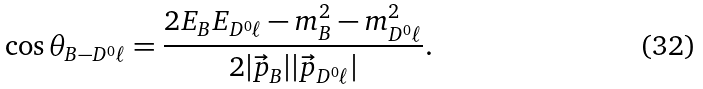<formula> <loc_0><loc_0><loc_500><loc_500>\cos \theta _ { B - D ^ { 0 } \ell } = \frac { 2 E _ { B } E _ { D ^ { 0 } \ell } - m _ { B } ^ { 2 } - m _ { D ^ { 0 } \ell } ^ { 2 } } { 2 | \vec { p } _ { B } | | \vec { p } _ { D ^ { 0 } \ell } | } .</formula> 